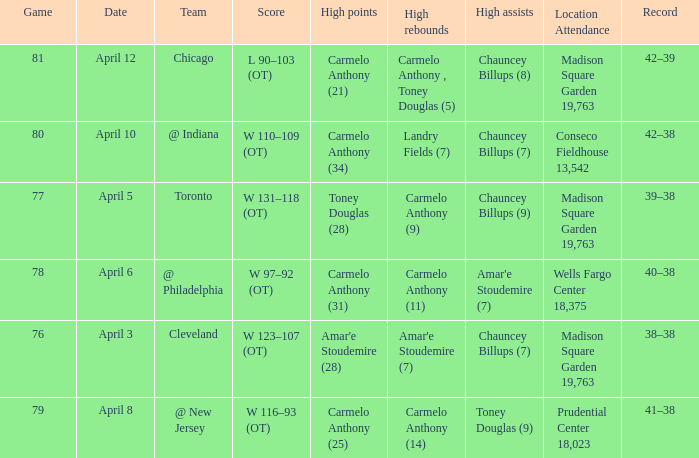Name the location attendance april 5 Madison Square Garden 19,763. 